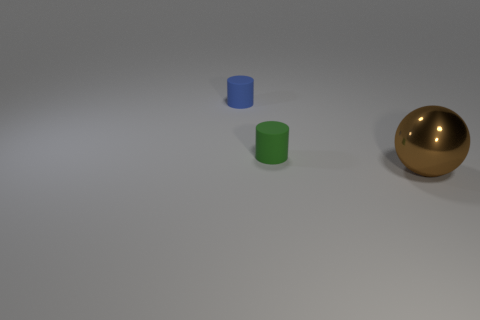Add 2 tiny blue matte things. How many objects exist? 5 Subtract all balls. How many objects are left? 2 Add 2 balls. How many balls exist? 3 Subtract 0 gray cylinders. How many objects are left? 3 Subtract all tiny brown balls. Subtract all small green cylinders. How many objects are left? 2 Add 3 small matte objects. How many small matte objects are left? 5 